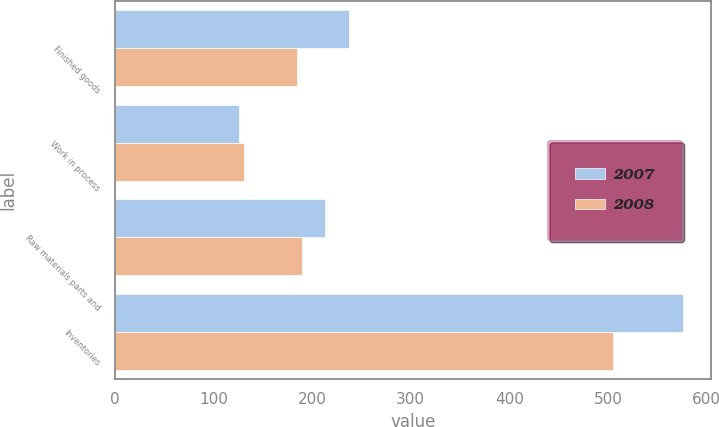Convert chart to OTSL. <chart><loc_0><loc_0><loc_500><loc_500><stacked_bar_chart><ecel><fcel>Finished goods<fcel>Work in process<fcel>Raw materials parts and<fcel>Inventories<nl><fcel>2007<fcel>237<fcel>125.9<fcel>212.6<fcel>575.5<nl><fcel>2008<fcel>184.9<fcel>130.4<fcel>189.4<fcel>504.7<nl></chart> 